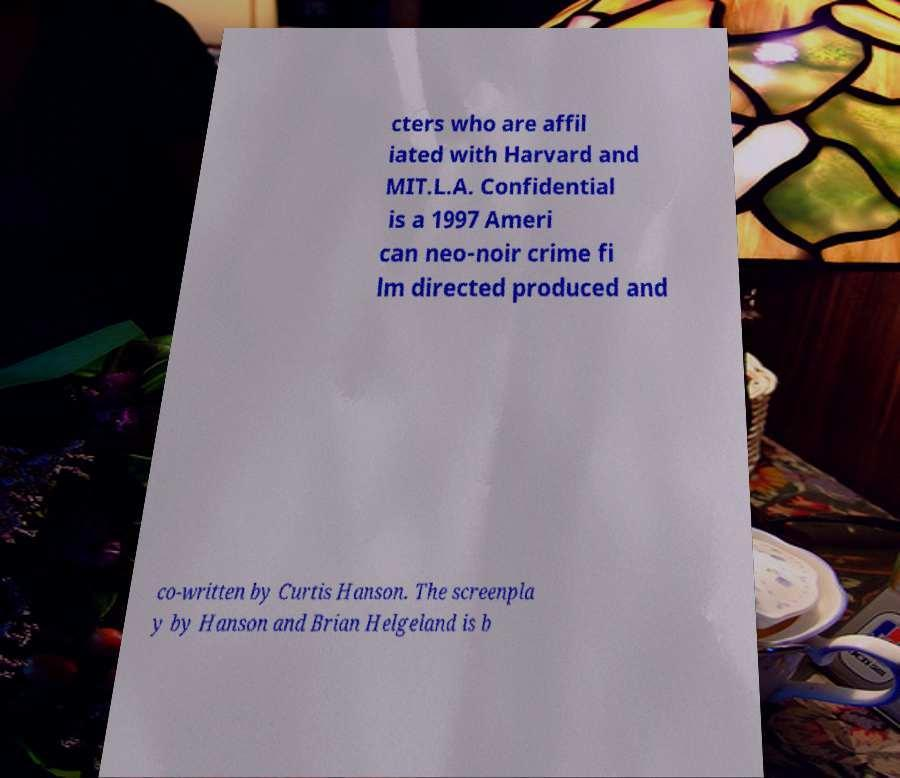Please identify and transcribe the text found in this image. cters who are affil iated with Harvard and MIT.L.A. Confidential is a 1997 Ameri can neo-noir crime fi lm directed produced and co-written by Curtis Hanson. The screenpla y by Hanson and Brian Helgeland is b 